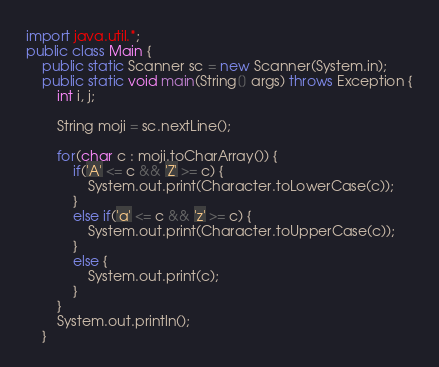Convert code to text. <code><loc_0><loc_0><loc_500><loc_500><_Java_>import java.util.*;
public class Main {
    public static Scanner sc = new Scanner(System.in);
    public static void main(String[] args) throws Exception {
    	int i, j;
    	
    	String moji = sc.nextLine();
    	
    	for(char c : moji.toCharArray()) {
    		if('A' <= c && 'Z' >= c) {
    			System.out.print(Character.toLowerCase(c));
    		}
    		else if('a' <= c && 'z' >= c) {
    			System.out.print(Character.toUpperCase(c));
    		}
    		else {
    			System.out.print(c);
    		}
    	}
    	System.out.println();
    }

</code> 